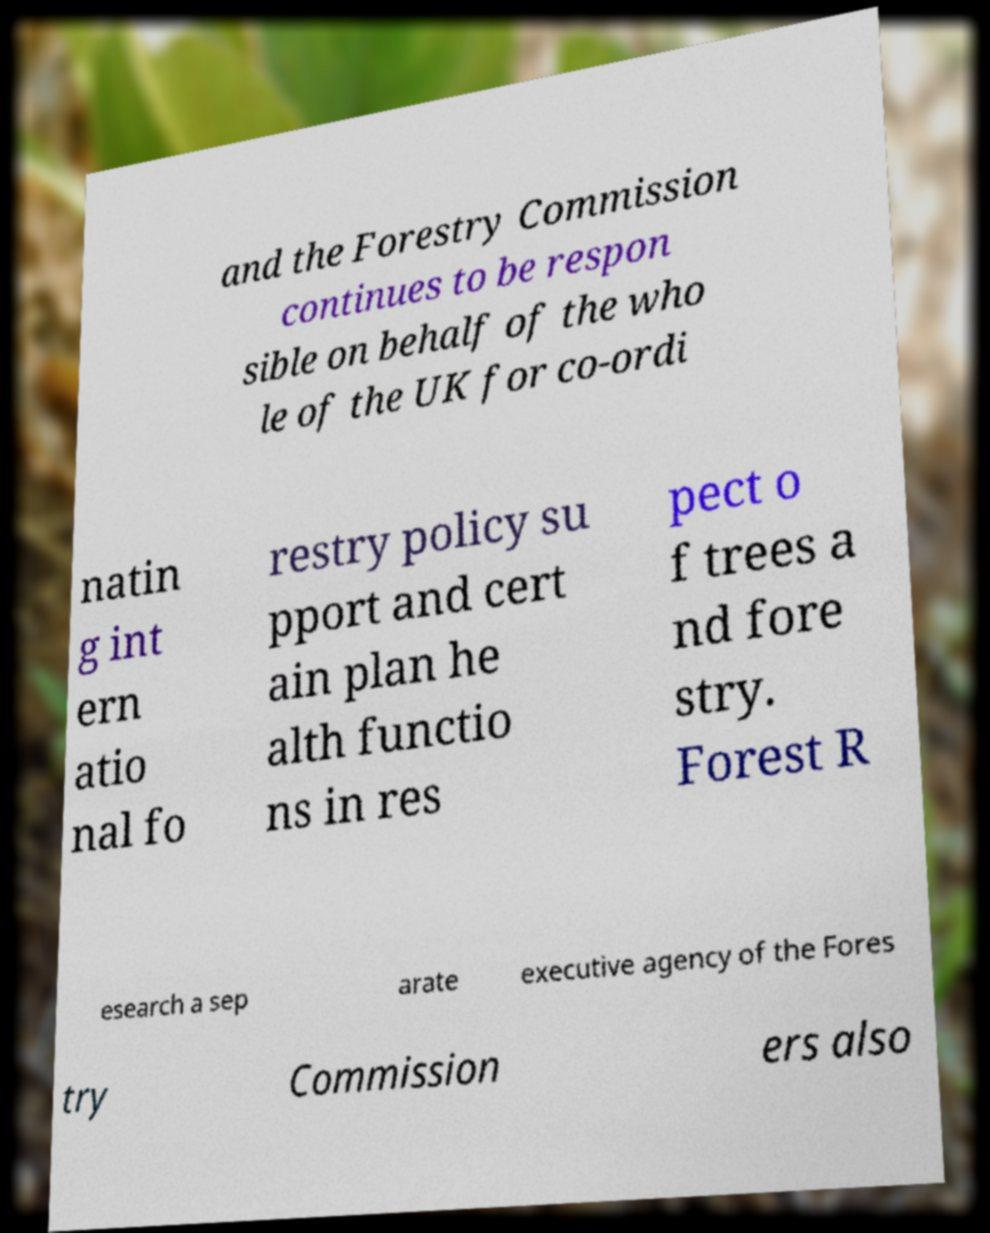Can you read and provide the text displayed in the image?This photo seems to have some interesting text. Can you extract and type it out for me? and the Forestry Commission continues to be respon sible on behalf of the who le of the UK for co-ordi natin g int ern atio nal fo restry policy su pport and cert ain plan he alth functio ns in res pect o f trees a nd fore stry. Forest R esearch a sep arate executive agency of the Fores try Commission ers also 